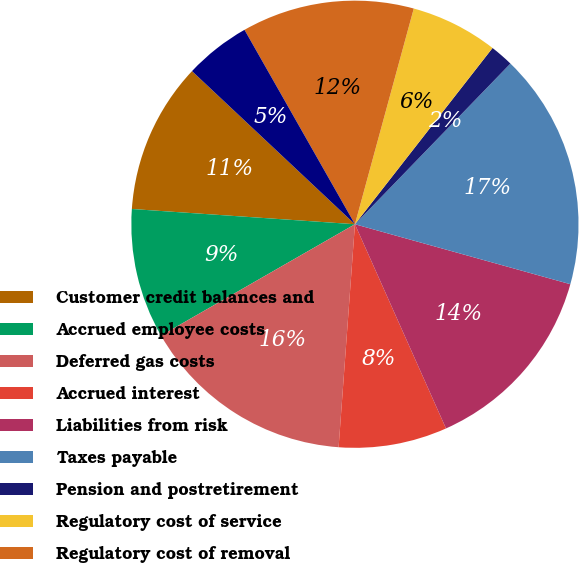Convert chart. <chart><loc_0><loc_0><loc_500><loc_500><pie_chart><fcel>Customer credit balances and<fcel>Accrued employee costs<fcel>Deferred gas costs<fcel>Accrued interest<fcel>Liabilities from risk<fcel>Taxes payable<fcel>Pension and postretirement<fcel>Regulatory cost of service<fcel>Regulatory cost of removal<fcel>APT annual adjustment<nl><fcel>10.92%<fcel>9.38%<fcel>15.54%<fcel>7.84%<fcel>14.0%<fcel>17.08%<fcel>1.69%<fcel>6.31%<fcel>12.46%<fcel>4.77%<nl></chart> 